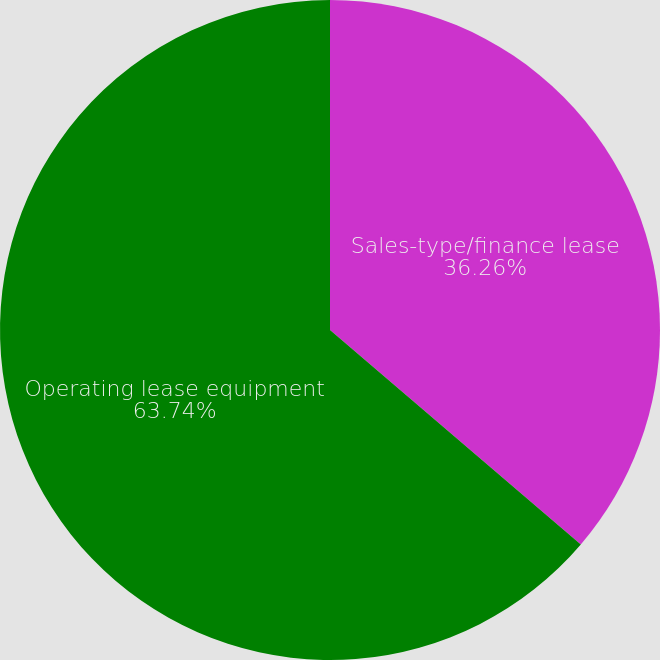<chart> <loc_0><loc_0><loc_500><loc_500><pie_chart><fcel>Sales-type/finance lease<fcel>Operating lease equipment<nl><fcel>36.26%<fcel>63.74%<nl></chart> 